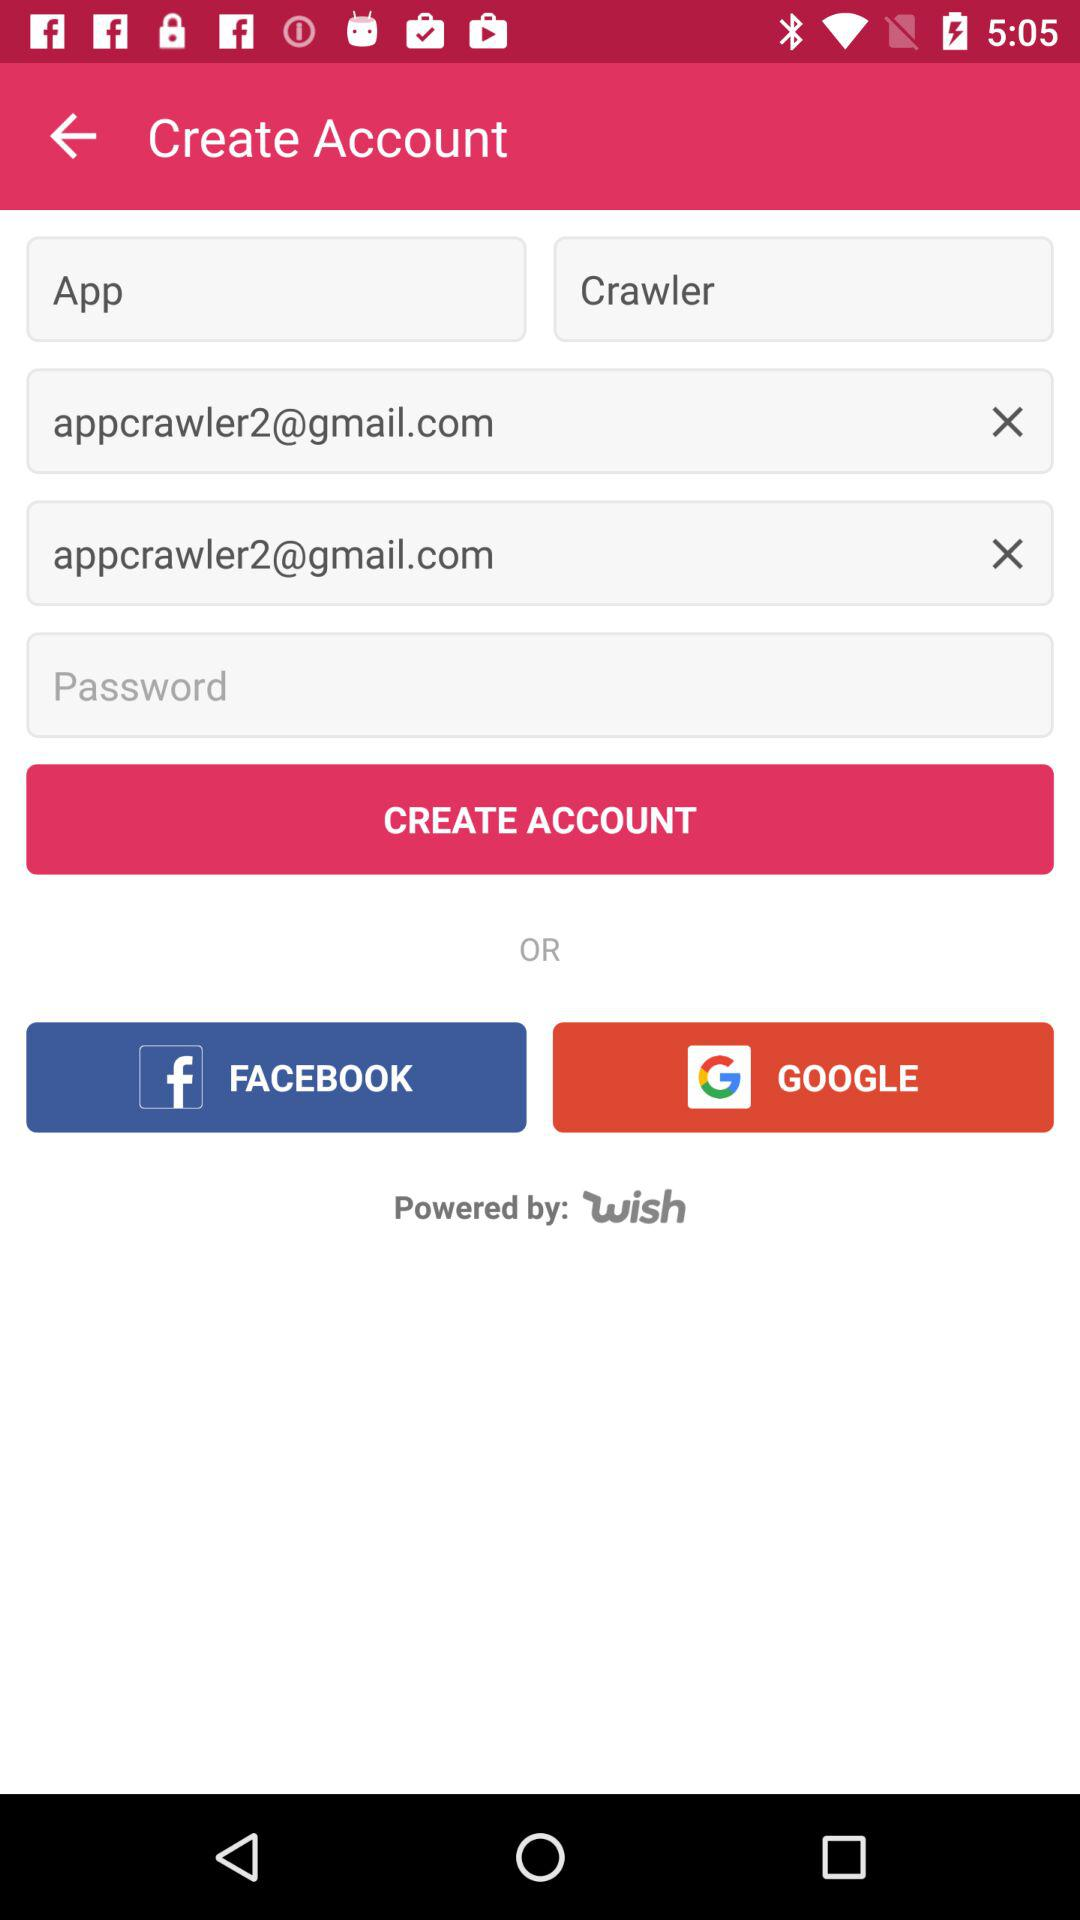How many characters are required to create a password?
When the provided information is insufficient, respond with <no answer>. <no answer> 